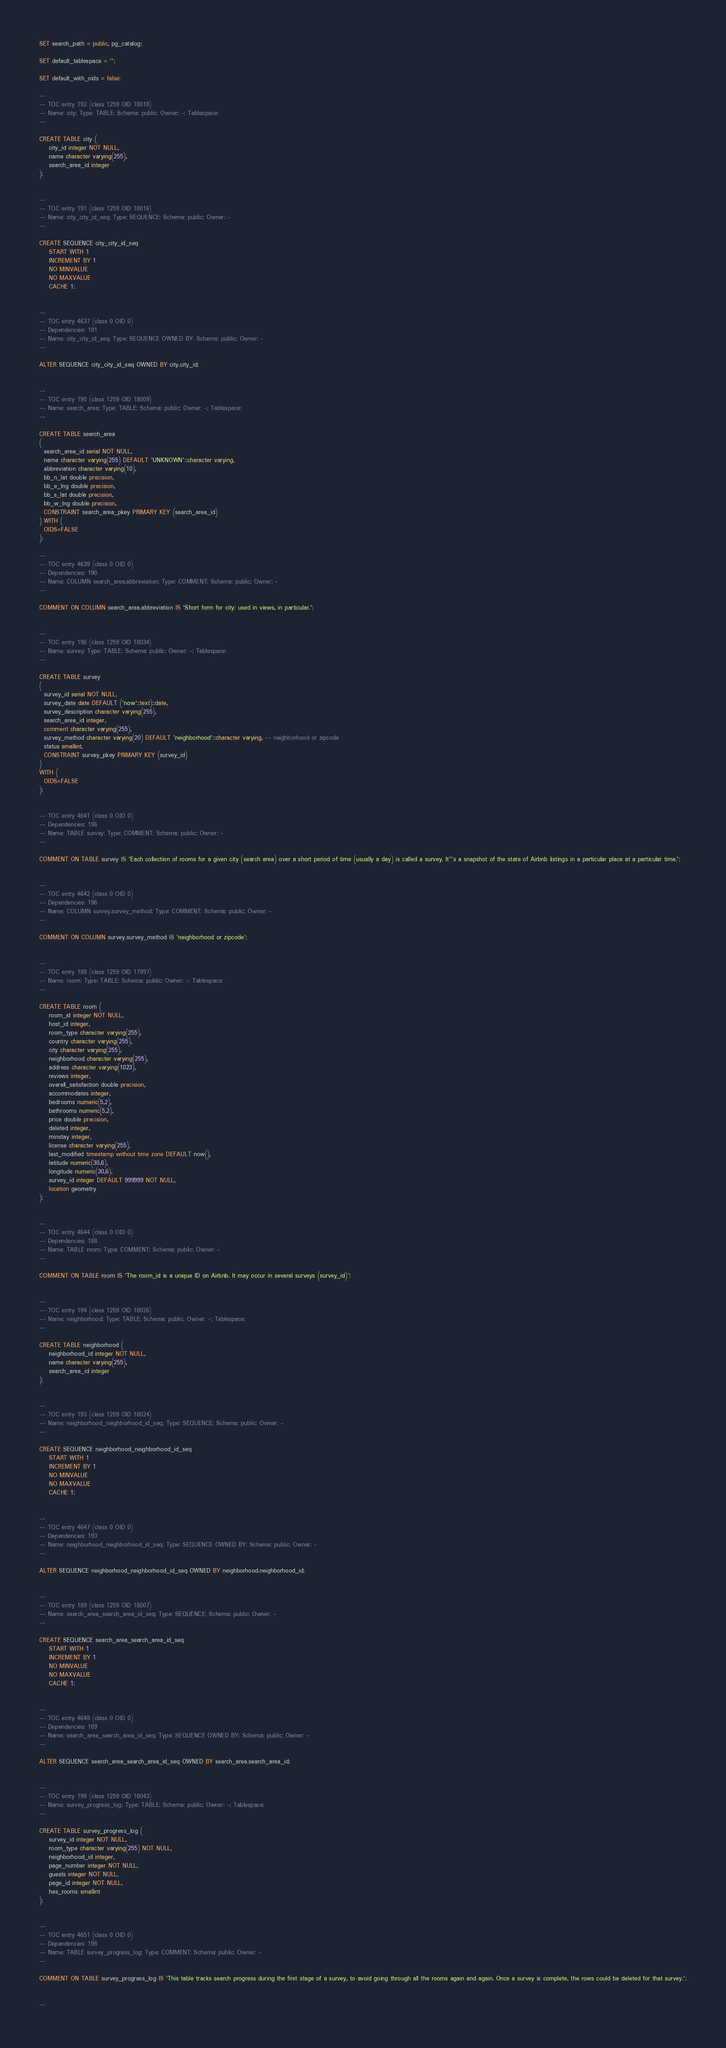<code> <loc_0><loc_0><loc_500><loc_500><_SQL_>SET search_path = public, pg_catalog;

SET default_tablespace = '';

SET default_with_oids = false;

--
-- TOC entry 192 (class 1259 OID 18018)
-- Name: city; Type: TABLE; Schema: public; Owner: -; Tablespace: 
--

CREATE TABLE city (
    city_id integer NOT NULL,
    name character varying(255),
    search_area_id integer
);


--
-- TOC entry 191 (class 1259 OID 18016)
-- Name: city_city_id_seq; Type: SEQUENCE; Schema: public; Owner: -
--

CREATE SEQUENCE city_city_id_seq
    START WITH 1
    INCREMENT BY 1
    NO MINVALUE
    NO MAXVALUE
    CACHE 1;


--
-- TOC entry 4637 (class 0 OID 0)
-- Dependencies: 191
-- Name: city_city_id_seq; Type: SEQUENCE OWNED BY; Schema: public; Owner: -
--

ALTER SEQUENCE city_city_id_seq OWNED BY city.city_id;


--
-- TOC entry 190 (class 1259 OID 18009)
-- Name: search_area; Type: TABLE; Schema: public; Owner: -; Tablespace: 
--

CREATE TABLE search_area
(
  search_area_id serial NOT NULL,
  name character varying(255) DEFAULT 'UNKNOWN'::character varying,
  abbreviation character varying(10),
  bb_n_lat double precision,
  bb_e_lng double precision,
  bb_s_lat double precision,
  bb_w_lng double precision,
  CONSTRAINT search_area_pkey PRIMARY KEY (search_area_id)
) WITH (
  OIDS=FALSE
);

--
-- TOC entry 4639 (class 0 OID 0)
-- Dependencies: 190
-- Name: COLUMN search_area.abbreviation; Type: COMMENT; Schema: public; Owner: -
--

COMMENT ON COLUMN search_area.abbreviation IS 'Short form for city: used in views, in particular.';


--
-- TOC entry 196 (class 1259 OID 18034)
-- Name: survey; Type: TABLE; Schema: public; Owner: -; Tablespace: 
--

CREATE TABLE survey
(
  survey_id serial NOT NULL,
  survey_date date DEFAULT ('now'::text)::date,
  survey_description character varying(255),
  search_area_id integer,
  comment character varying(255),
  survey_method character varying(20) DEFAULT 'neighborhood'::character varying, -- neighborhood or zipcode
  status smallint,
  CONSTRAINT survey_pkey PRIMARY KEY (survey_id)
)
WITH (
  OIDS=FALSE
);


-- TOC entry 4641 (class 0 OID 0)
-- Dependencies: 196
-- Name: TABLE survey; Type: COMMENT; Schema: public; Owner: -
--

COMMENT ON TABLE survey IS 'Each collection of rooms for a given city (search area) over a short period of time (usually a day) is called a survey. It''s a snapshot of the state of Airbnb listings in a particular place at a particular time.';


--
-- TOC entry 4642 (class 0 OID 0)
-- Dependencies: 196
-- Name: COLUMN survey.survey_method; Type: COMMENT; Schema: public; Owner: -
--

COMMENT ON COLUMN survey.survey_method IS 'neighborhood or zipcode';


--
-- TOC entry 188 (class 1259 OID 17997)
-- Name: room; Type: TABLE; Schema: public; Owner: -; Tablespace: 
--

CREATE TABLE room (
    room_id integer NOT NULL,
    host_id integer,
    room_type character varying(255),
    country character varying(255),
    city character varying(255),
    neighborhood character varying(255),
    address character varying(1023),
    reviews integer,
    overall_satisfaction double precision,
    accommodates integer,
    bedrooms numeric(5,2),
    bathrooms numeric(5,2),
    price double precision,
    deleted integer,
    minstay integer,
    license character varying(255),
    last_modified timestamp without time zone DEFAULT now(),
    latitude numeric(30,6),
    longitude numeric(30,6),
    survey_id integer DEFAULT 999999 NOT NULL,
    location geometry
);


--
-- TOC entry 4644 (class 0 OID 0)
-- Dependencies: 188
-- Name: TABLE room; Type: COMMENT; Schema: public; Owner: -
--

COMMENT ON TABLE room IS 'The room_id is a unique ID on Airbnb. It may occur in several surveys (survey_id)';


--
-- TOC entry 194 (class 1259 OID 18026)
-- Name: neighborhood; Type: TABLE; Schema: public; Owner: -; Tablespace: 
--

CREATE TABLE neighborhood (
    neighborhood_id integer NOT NULL,
    name character varying(255),
    search_area_id integer
);


--
-- TOC entry 193 (class 1259 OID 18024)
-- Name: neighborhood_neighborhood_id_seq; Type: SEQUENCE; Schema: public; Owner: -
--

CREATE SEQUENCE neighborhood_neighborhood_id_seq
    START WITH 1
    INCREMENT BY 1
    NO MINVALUE
    NO MAXVALUE
    CACHE 1;


--
-- TOC entry 4647 (class 0 OID 0)
-- Dependencies: 193
-- Name: neighborhood_neighborhood_id_seq; Type: SEQUENCE OWNED BY; Schema: public; Owner: -
--

ALTER SEQUENCE neighborhood_neighborhood_id_seq OWNED BY neighborhood.neighborhood_id;


--
-- TOC entry 189 (class 1259 OID 18007)
-- Name: search_area_search_area_id_seq; Type: SEQUENCE; Schema: public; Owner: -
--

CREATE SEQUENCE search_area_search_area_id_seq
    START WITH 1
    INCREMENT BY 1
    NO MINVALUE
    NO MAXVALUE
    CACHE 1;


--
-- TOC entry 4649 (class 0 OID 0)
-- Dependencies: 189
-- Name: search_area_search_area_id_seq; Type: SEQUENCE OWNED BY; Schema: public; Owner: -
--

ALTER SEQUENCE search_area_search_area_id_seq OWNED BY search_area.search_area_id;


--
-- TOC entry 198 (class 1259 OID 18043)
-- Name: survey_progress_log; Type: TABLE; Schema: public; Owner: -; Tablespace: 
--

CREATE TABLE survey_progress_log (
    survey_id integer NOT NULL,
    room_type character varying(255) NOT NULL,
    neighborhood_id integer,
    page_number integer NOT NULL,
    guests integer NOT NULL,
    page_id integer NOT NULL,
    has_rooms smallint
);


--
-- TOC entry 4651 (class 0 OID 0)
-- Dependencies: 198
-- Name: TABLE survey_progress_log; Type: COMMENT; Schema: public; Owner: -
--

COMMENT ON TABLE survey_progress_log IS 'This table tracks search progress during the first stage of a survey, to avoid going through all the rooms again and again. Once a survey is complete, the rows could be deleted for that survey.';


--</code> 